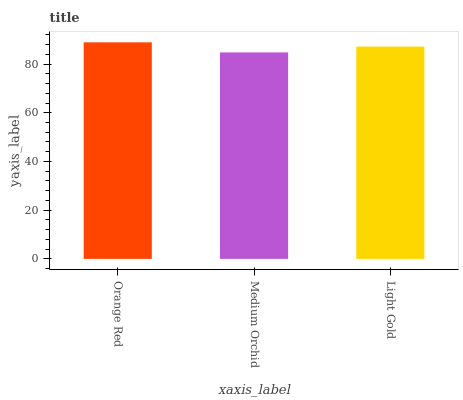Is Medium Orchid the minimum?
Answer yes or no. Yes. Is Orange Red the maximum?
Answer yes or no. Yes. Is Light Gold the minimum?
Answer yes or no. No. Is Light Gold the maximum?
Answer yes or no. No. Is Light Gold greater than Medium Orchid?
Answer yes or no. Yes. Is Medium Orchid less than Light Gold?
Answer yes or no. Yes. Is Medium Orchid greater than Light Gold?
Answer yes or no. No. Is Light Gold less than Medium Orchid?
Answer yes or no. No. Is Light Gold the high median?
Answer yes or no. Yes. Is Light Gold the low median?
Answer yes or no. Yes. Is Orange Red the high median?
Answer yes or no. No. Is Orange Red the low median?
Answer yes or no. No. 